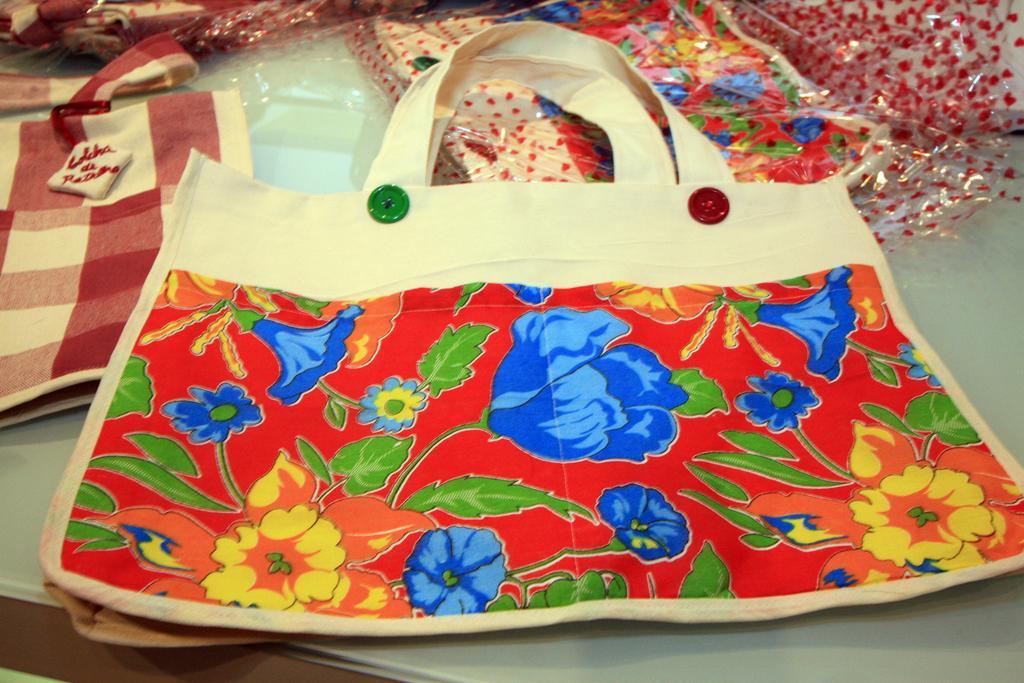In one or two sentences, can you explain what this image depicts? there are cloth bags. in the front bag there are 2 buttons which are red and green in color. the bag has a floral print on it. at the back there are covers. 